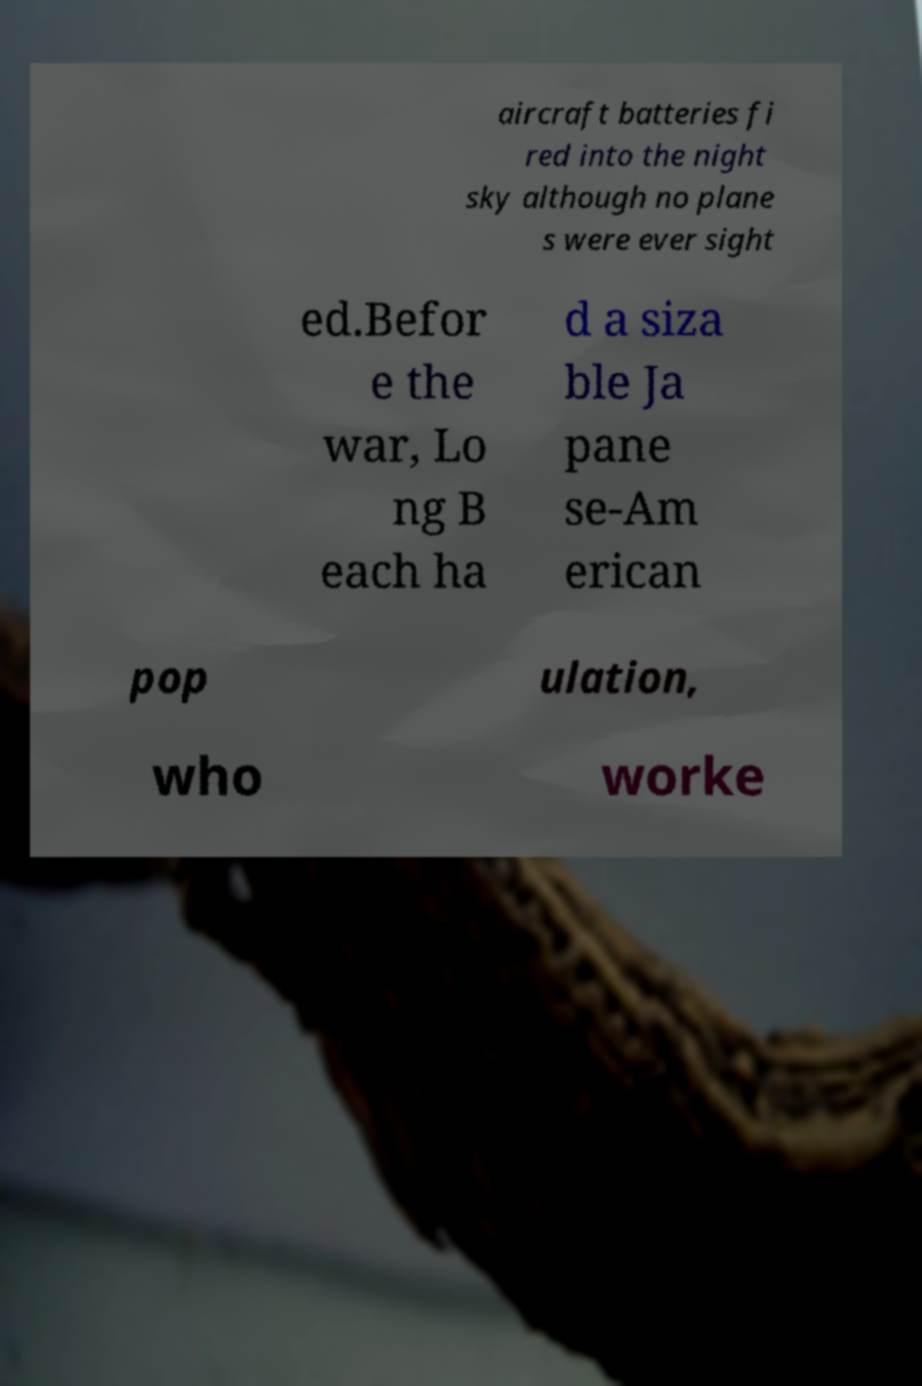Could you extract and type out the text from this image? aircraft batteries fi red into the night sky although no plane s were ever sight ed.Befor e the war, Lo ng B each ha d a siza ble Ja pane se-Am erican pop ulation, who worke 